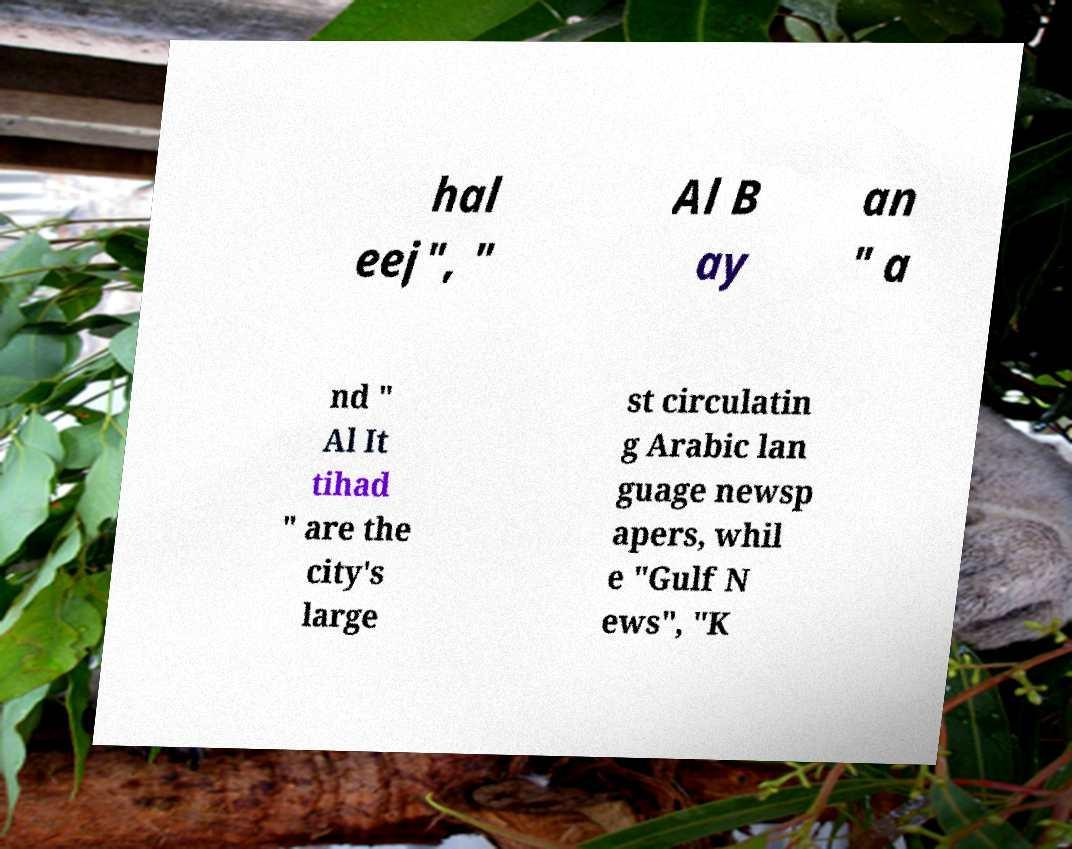Please read and relay the text visible in this image. What does it say? hal eej", " Al B ay an " a nd " Al It tihad " are the city's large st circulatin g Arabic lan guage newsp apers, whil e "Gulf N ews", "K 